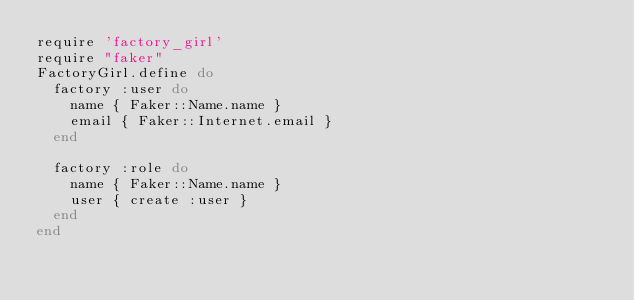<code> <loc_0><loc_0><loc_500><loc_500><_Ruby_>require 'factory_girl'
require "faker"
FactoryGirl.define do
  factory :user do
    name { Faker::Name.name }
    email { Faker::Internet.email }
  end

  factory :role do
    name { Faker::Name.name }
    user { create :user }
  end
end
</code> 